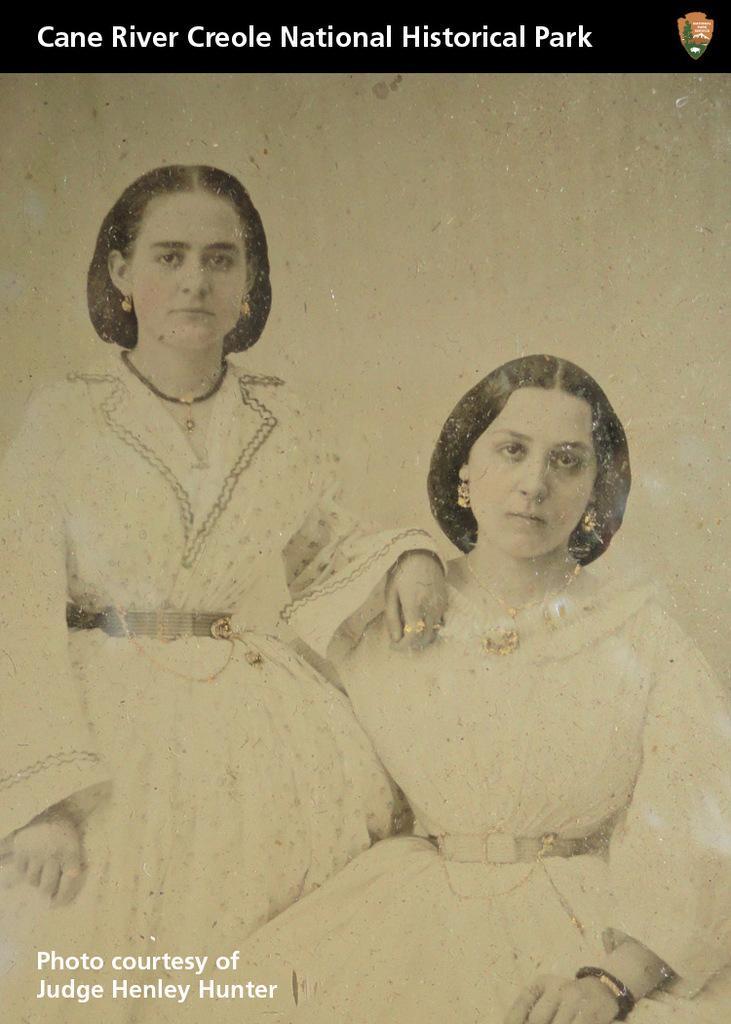In one or two sentences, can you explain what this image depicts? In this picture I can see a poster, there are two persons, there are words and a logo on the poster. 